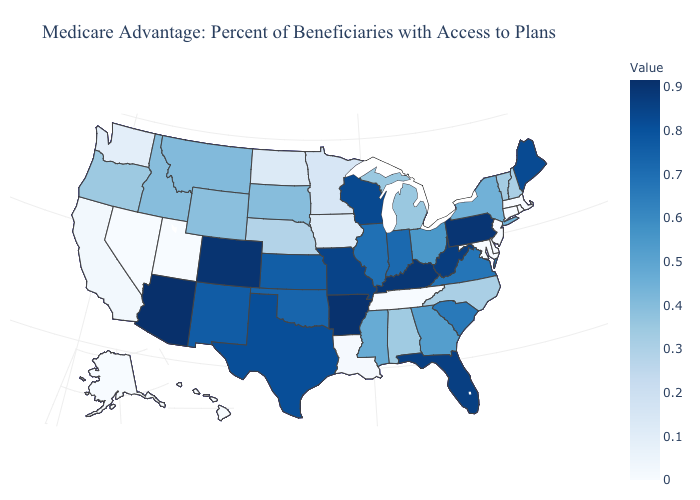Does Mississippi have the lowest value in the South?
Short answer required. No. Does Maine have the lowest value in the Northeast?
Give a very brief answer. No. Among the states that border Alabama , does Florida have the highest value?
Quick response, please. Yes. Does North Carolina have the lowest value in the South?
Give a very brief answer. No. Which states have the lowest value in the USA?
Be succinct. Connecticut, Delaware, Hawaii, Massachusetts, Maryland, New Jersey, Nevada, Rhode Island, Alaska, Tennessee, Utah. 